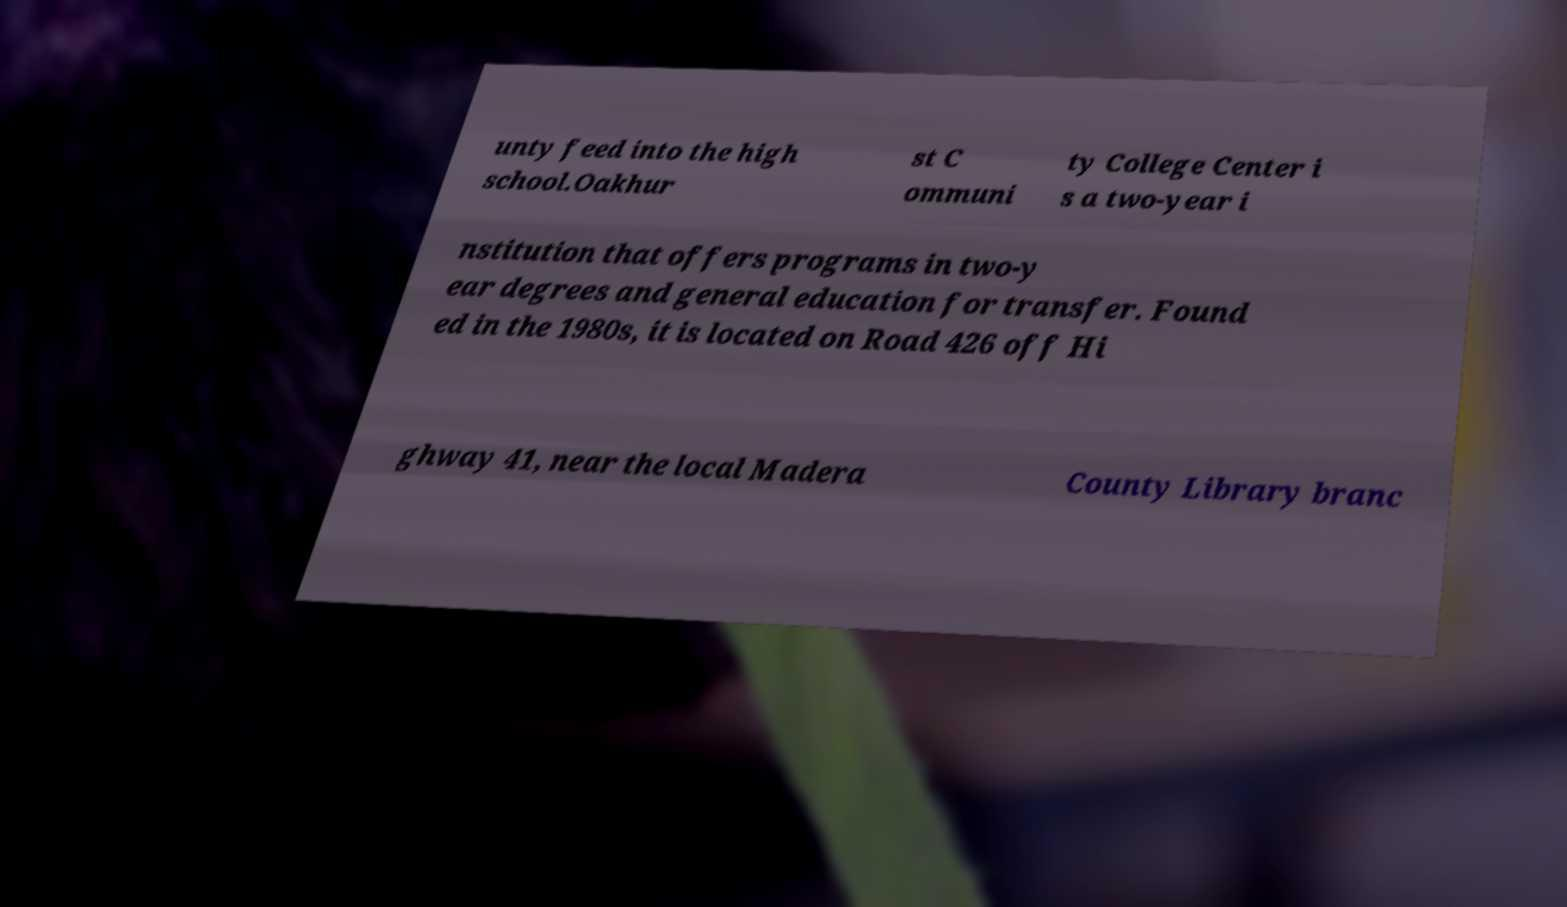Can you accurately transcribe the text from the provided image for me? unty feed into the high school.Oakhur st C ommuni ty College Center i s a two-year i nstitution that offers programs in two-y ear degrees and general education for transfer. Found ed in the 1980s, it is located on Road 426 off Hi ghway 41, near the local Madera County Library branc 